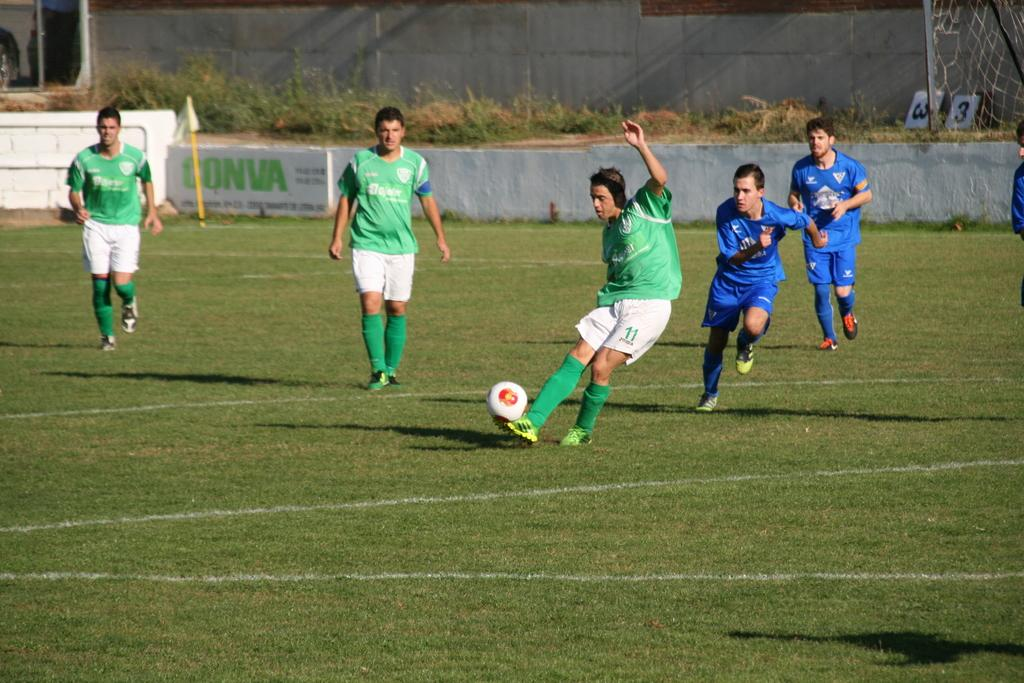Provide a one-sentence caption for the provided image. Two teams of soccer players  wearing a blue and a green uniform in a Conva field. 